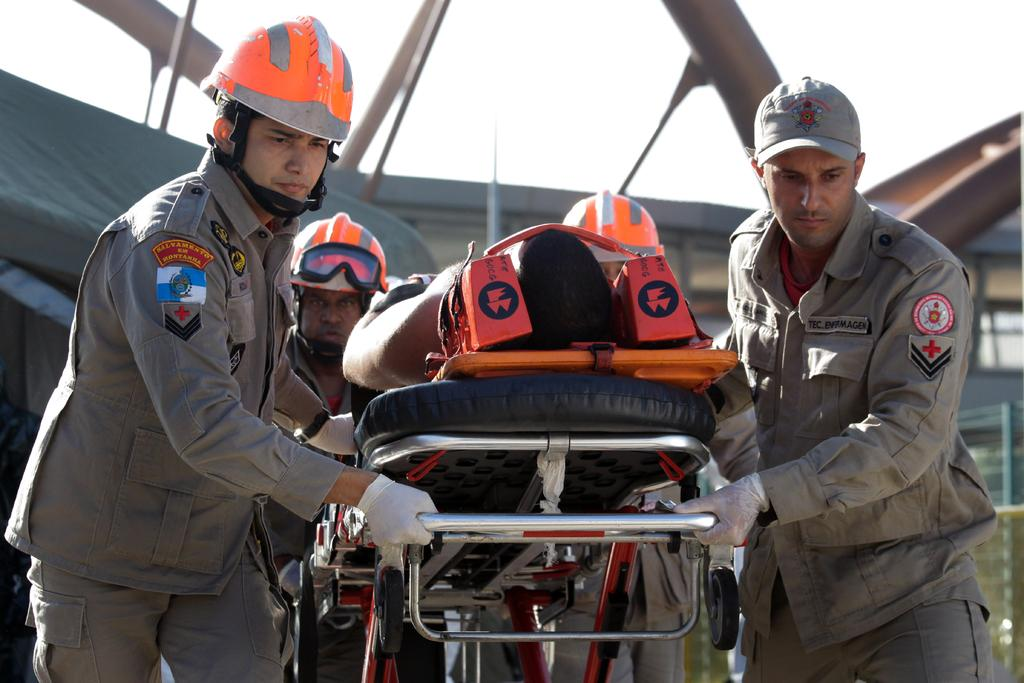How many people are in the image? There are four persons in the image. What are the four persons doing? The four persons are holding a stretcher. Is there anyone on the stretcher? Yes, there is a person on the stretcher. What can be seen in the background of the image? There is a tent and a building visible in the background. What is visible at the top of the image? The sky is visible at the top of the image. What type of note is the person on the stretcher writing in the image? There is no note present in the image, as the person on the stretcher is not shown writing anything. What is the story behind the number of people holding the stretcher in the image? There is no specific story behind the number of people holding the stretcher in the image; it is simply a depiction of a situation where multiple people are assisting someone on a stretcher. 